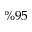Convert formula to latex. <formula><loc_0><loc_0><loc_500><loc_500>\% 9 5</formula> 